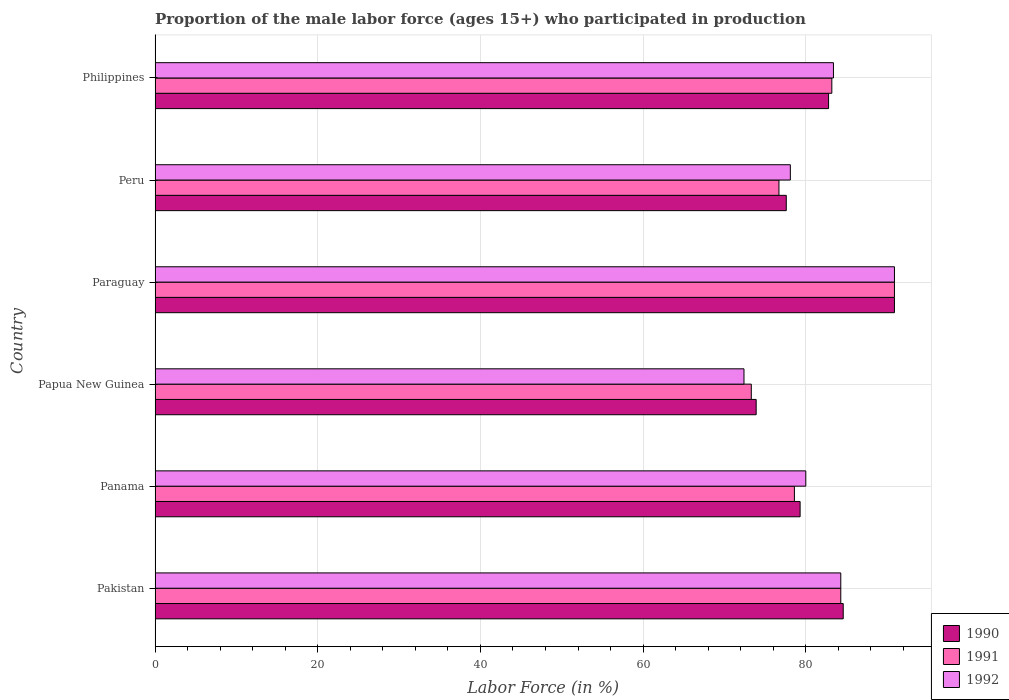How many groups of bars are there?
Offer a very short reply. 6. Are the number of bars per tick equal to the number of legend labels?
Your response must be concise. Yes. Are the number of bars on each tick of the Y-axis equal?
Ensure brevity in your answer.  Yes. What is the label of the 2nd group of bars from the top?
Give a very brief answer. Peru. What is the proportion of the male labor force who participated in production in 1991 in Papua New Guinea?
Ensure brevity in your answer.  73.3. Across all countries, what is the maximum proportion of the male labor force who participated in production in 1990?
Provide a short and direct response. 90.9. Across all countries, what is the minimum proportion of the male labor force who participated in production in 1991?
Provide a short and direct response. 73.3. In which country was the proportion of the male labor force who participated in production in 1991 maximum?
Your answer should be very brief. Paraguay. In which country was the proportion of the male labor force who participated in production in 1991 minimum?
Your answer should be very brief. Papua New Guinea. What is the total proportion of the male labor force who participated in production in 1991 in the graph?
Provide a short and direct response. 487. What is the difference between the proportion of the male labor force who participated in production in 1992 in Pakistan and that in Paraguay?
Your answer should be compact. -6.6. What is the difference between the proportion of the male labor force who participated in production in 1990 in Peru and the proportion of the male labor force who participated in production in 1992 in Pakistan?
Your answer should be very brief. -6.7. What is the average proportion of the male labor force who participated in production in 1991 per country?
Offer a very short reply. 81.17. In how many countries, is the proportion of the male labor force who participated in production in 1992 greater than 80 %?
Offer a very short reply. 3. What is the ratio of the proportion of the male labor force who participated in production in 1991 in Panama to that in Paraguay?
Provide a short and direct response. 0.86. Is the difference between the proportion of the male labor force who participated in production in 1991 in Papua New Guinea and Peru greater than the difference between the proportion of the male labor force who participated in production in 1990 in Papua New Guinea and Peru?
Offer a terse response. Yes. What is the difference between the highest and the second highest proportion of the male labor force who participated in production in 1992?
Your answer should be very brief. 6.6. What is the difference between the highest and the lowest proportion of the male labor force who participated in production in 1992?
Offer a very short reply. 18.5. In how many countries, is the proportion of the male labor force who participated in production in 1990 greater than the average proportion of the male labor force who participated in production in 1990 taken over all countries?
Your response must be concise. 3. Is the sum of the proportion of the male labor force who participated in production in 1991 in Panama and Peru greater than the maximum proportion of the male labor force who participated in production in 1990 across all countries?
Make the answer very short. Yes. What does the 1st bar from the top in Peru represents?
Your response must be concise. 1992. How many bars are there?
Give a very brief answer. 18. What is the difference between two consecutive major ticks on the X-axis?
Provide a short and direct response. 20. Does the graph contain any zero values?
Your answer should be very brief. No. How many legend labels are there?
Your response must be concise. 3. How are the legend labels stacked?
Your response must be concise. Vertical. What is the title of the graph?
Give a very brief answer. Proportion of the male labor force (ages 15+) who participated in production. Does "1984" appear as one of the legend labels in the graph?
Your answer should be compact. No. What is the label or title of the Y-axis?
Offer a terse response. Country. What is the Labor Force (in %) of 1990 in Pakistan?
Provide a short and direct response. 84.6. What is the Labor Force (in %) of 1991 in Pakistan?
Your answer should be compact. 84.3. What is the Labor Force (in %) in 1992 in Pakistan?
Give a very brief answer. 84.3. What is the Labor Force (in %) in 1990 in Panama?
Provide a short and direct response. 79.3. What is the Labor Force (in %) in 1991 in Panama?
Make the answer very short. 78.6. What is the Labor Force (in %) of 1990 in Papua New Guinea?
Your response must be concise. 73.9. What is the Labor Force (in %) in 1991 in Papua New Guinea?
Provide a succinct answer. 73.3. What is the Labor Force (in %) in 1992 in Papua New Guinea?
Provide a short and direct response. 72.4. What is the Labor Force (in %) of 1990 in Paraguay?
Keep it short and to the point. 90.9. What is the Labor Force (in %) in 1991 in Paraguay?
Make the answer very short. 90.9. What is the Labor Force (in %) of 1992 in Paraguay?
Ensure brevity in your answer.  90.9. What is the Labor Force (in %) in 1990 in Peru?
Your response must be concise. 77.6. What is the Labor Force (in %) in 1991 in Peru?
Your response must be concise. 76.7. What is the Labor Force (in %) in 1992 in Peru?
Give a very brief answer. 78.1. What is the Labor Force (in %) of 1990 in Philippines?
Provide a short and direct response. 82.8. What is the Labor Force (in %) of 1991 in Philippines?
Make the answer very short. 83.2. What is the Labor Force (in %) in 1992 in Philippines?
Provide a succinct answer. 83.4. Across all countries, what is the maximum Labor Force (in %) in 1990?
Provide a short and direct response. 90.9. Across all countries, what is the maximum Labor Force (in %) of 1991?
Provide a short and direct response. 90.9. Across all countries, what is the maximum Labor Force (in %) of 1992?
Your answer should be compact. 90.9. Across all countries, what is the minimum Labor Force (in %) of 1990?
Ensure brevity in your answer.  73.9. Across all countries, what is the minimum Labor Force (in %) of 1991?
Offer a terse response. 73.3. Across all countries, what is the minimum Labor Force (in %) in 1992?
Give a very brief answer. 72.4. What is the total Labor Force (in %) of 1990 in the graph?
Provide a short and direct response. 489.1. What is the total Labor Force (in %) of 1991 in the graph?
Ensure brevity in your answer.  487. What is the total Labor Force (in %) in 1992 in the graph?
Make the answer very short. 489.1. What is the difference between the Labor Force (in %) in 1991 in Pakistan and that in Panama?
Your response must be concise. 5.7. What is the difference between the Labor Force (in %) of 1992 in Pakistan and that in Panama?
Provide a succinct answer. 4.3. What is the difference between the Labor Force (in %) of 1990 in Pakistan and that in Paraguay?
Your answer should be compact. -6.3. What is the difference between the Labor Force (in %) in 1991 in Pakistan and that in Paraguay?
Give a very brief answer. -6.6. What is the difference between the Labor Force (in %) in 1990 in Pakistan and that in Peru?
Provide a succinct answer. 7. What is the difference between the Labor Force (in %) of 1992 in Pakistan and that in Philippines?
Provide a short and direct response. 0.9. What is the difference between the Labor Force (in %) of 1990 in Panama and that in Papua New Guinea?
Offer a terse response. 5.4. What is the difference between the Labor Force (in %) in 1991 in Panama and that in Paraguay?
Give a very brief answer. -12.3. What is the difference between the Labor Force (in %) in 1992 in Panama and that in Paraguay?
Provide a succinct answer. -10.9. What is the difference between the Labor Force (in %) in 1990 in Panama and that in Peru?
Provide a short and direct response. 1.7. What is the difference between the Labor Force (in %) of 1991 in Panama and that in Peru?
Provide a succinct answer. 1.9. What is the difference between the Labor Force (in %) of 1992 in Panama and that in Peru?
Provide a succinct answer. 1.9. What is the difference between the Labor Force (in %) in 1991 in Panama and that in Philippines?
Your answer should be compact. -4.6. What is the difference between the Labor Force (in %) of 1991 in Papua New Guinea and that in Paraguay?
Provide a succinct answer. -17.6. What is the difference between the Labor Force (in %) in 1992 in Papua New Guinea and that in Paraguay?
Ensure brevity in your answer.  -18.5. What is the difference between the Labor Force (in %) of 1990 in Papua New Guinea and that in Peru?
Make the answer very short. -3.7. What is the difference between the Labor Force (in %) of 1992 in Papua New Guinea and that in Peru?
Provide a succinct answer. -5.7. What is the difference between the Labor Force (in %) of 1990 in Papua New Guinea and that in Philippines?
Make the answer very short. -8.9. What is the difference between the Labor Force (in %) of 1991 in Paraguay and that in Peru?
Give a very brief answer. 14.2. What is the difference between the Labor Force (in %) of 1990 in Peru and that in Philippines?
Keep it short and to the point. -5.2. What is the difference between the Labor Force (in %) of 1991 in Peru and that in Philippines?
Ensure brevity in your answer.  -6.5. What is the difference between the Labor Force (in %) in 1991 in Pakistan and the Labor Force (in %) in 1992 in Panama?
Provide a succinct answer. 4.3. What is the difference between the Labor Force (in %) of 1990 in Pakistan and the Labor Force (in %) of 1992 in Papua New Guinea?
Offer a very short reply. 12.2. What is the difference between the Labor Force (in %) in 1991 in Pakistan and the Labor Force (in %) in 1992 in Papua New Guinea?
Ensure brevity in your answer.  11.9. What is the difference between the Labor Force (in %) of 1990 in Pakistan and the Labor Force (in %) of 1991 in Paraguay?
Provide a short and direct response. -6.3. What is the difference between the Labor Force (in %) of 1990 in Pakistan and the Labor Force (in %) of 1992 in Paraguay?
Offer a terse response. -6.3. What is the difference between the Labor Force (in %) in 1990 in Pakistan and the Labor Force (in %) in 1991 in Philippines?
Offer a terse response. 1.4. What is the difference between the Labor Force (in %) in 1990 in Pakistan and the Labor Force (in %) in 1992 in Philippines?
Your answer should be compact. 1.2. What is the difference between the Labor Force (in %) in 1991 in Pakistan and the Labor Force (in %) in 1992 in Philippines?
Your response must be concise. 0.9. What is the difference between the Labor Force (in %) in 1990 in Panama and the Labor Force (in %) in 1991 in Papua New Guinea?
Offer a very short reply. 6. What is the difference between the Labor Force (in %) of 1990 in Panama and the Labor Force (in %) of 1991 in Paraguay?
Keep it short and to the point. -11.6. What is the difference between the Labor Force (in %) of 1990 in Panama and the Labor Force (in %) of 1992 in Paraguay?
Make the answer very short. -11.6. What is the difference between the Labor Force (in %) of 1991 in Panama and the Labor Force (in %) of 1992 in Paraguay?
Keep it short and to the point. -12.3. What is the difference between the Labor Force (in %) in 1991 in Panama and the Labor Force (in %) in 1992 in Philippines?
Make the answer very short. -4.8. What is the difference between the Labor Force (in %) in 1991 in Papua New Guinea and the Labor Force (in %) in 1992 in Paraguay?
Provide a short and direct response. -17.6. What is the difference between the Labor Force (in %) in 1990 in Papua New Guinea and the Labor Force (in %) in 1991 in Peru?
Offer a terse response. -2.8. What is the difference between the Labor Force (in %) of 1990 in Papua New Guinea and the Labor Force (in %) of 1991 in Philippines?
Your answer should be very brief. -9.3. What is the difference between the Labor Force (in %) in 1990 in Papua New Guinea and the Labor Force (in %) in 1992 in Philippines?
Your answer should be very brief. -9.5. What is the difference between the Labor Force (in %) of 1990 in Paraguay and the Labor Force (in %) of 1991 in Peru?
Your answer should be very brief. 14.2. What is the difference between the Labor Force (in %) of 1991 in Paraguay and the Labor Force (in %) of 1992 in Philippines?
Offer a very short reply. 7.5. What is the difference between the Labor Force (in %) in 1990 in Peru and the Labor Force (in %) in 1991 in Philippines?
Your response must be concise. -5.6. What is the difference between the Labor Force (in %) in 1990 in Peru and the Labor Force (in %) in 1992 in Philippines?
Offer a very short reply. -5.8. What is the difference between the Labor Force (in %) of 1991 in Peru and the Labor Force (in %) of 1992 in Philippines?
Offer a very short reply. -6.7. What is the average Labor Force (in %) in 1990 per country?
Make the answer very short. 81.52. What is the average Labor Force (in %) in 1991 per country?
Keep it short and to the point. 81.17. What is the average Labor Force (in %) of 1992 per country?
Offer a terse response. 81.52. What is the difference between the Labor Force (in %) in 1990 and Labor Force (in %) in 1991 in Pakistan?
Make the answer very short. 0.3. What is the difference between the Labor Force (in %) in 1991 and Labor Force (in %) in 1992 in Panama?
Provide a succinct answer. -1.4. What is the difference between the Labor Force (in %) of 1990 and Labor Force (in %) of 1992 in Papua New Guinea?
Provide a short and direct response. 1.5. What is the difference between the Labor Force (in %) of 1990 and Labor Force (in %) of 1991 in Paraguay?
Give a very brief answer. 0. What is the difference between the Labor Force (in %) of 1991 and Labor Force (in %) of 1992 in Paraguay?
Your response must be concise. 0. What is the difference between the Labor Force (in %) of 1990 and Labor Force (in %) of 1992 in Peru?
Give a very brief answer. -0.5. What is the difference between the Labor Force (in %) in 1990 and Labor Force (in %) in 1991 in Philippines?
Offer a very short reply. -0.4. What is the difference between the Labor Force (in %) of 1991 and Labor Force (in %) of 1992 in Philippines?
Provide a short and direct response. -0.2. What is the ratio of the Labor Force (in %) in 1990 in Pakistan to that in Panama?
Your answer should be compact. 1.07. What is the ratio of the Labor Force (in %) of 1991 in Pakistan to that in Panama?
Make the answer very short. 1.07. What is the ratio of the Labor Force (in %) in 1992 in Pakistan to that in Panama?
Ensure brevity in your answer.  1.05. What is the ratio of the Labor Force (in %) in 1990 in Pakistan to that in Papua New Guinea?
Give a very brief answer. 1.14. What is the ratio of the Labor Force (in %) of 1991 in Pakistan to that in Papua New Guinea?
Your answer should be compact. 1.15. What is the ratio of the Labor Force (in %) in 1992 in Pakistan to that in Papua New Guinea?
Ensure brevity in your answer.  1.16. What is the ratio of the Labor Force (in %) of 1990 in Pakistan to that in Paraguay?
Offer a terse response. 0.93. What is the ratio of the Labor Force (in %) of 1991 in Pakistan to that in Paraguay?
Your response must be concise. 0.93. What is the ratio of the Labor Force (in %) in 1992 in Pakistan to that in Paraguay?
Provide a short and direct response. 0.93. What is the ratio of the Labor Force (in %) of 1990 in Pakistan to that in Peru?
Your answer should be very brief. 1.09. What is the ratio of the Labor Force (in %) in 1991 in Pakistan to that in Peru?
Keep it short and to the point. 1.1. What is the ratio of the Labor Force (in %) of 1992 in Pakistan to that in Peru?
Make the answer very short. 1.08. What is the ratio of the Labor Force (in %) in 1990 in Pakistan to that in Philippines?
Ensure brevity in your answer.  1.02. What is the ratio of the Labor Force (in %) of 1991 in Pakistan to that in Philippines?
Offer a very short reply. 1.01. What is the ratio of the Labor Force (in %) in 1992 in Pakistan to that in Philippines?
Offer a terse response. 1.01. What is the ratio of the Labor Force (in %) in 1990 in Panama to that in Papua New Guinea?
Ensure brevity in your answer.  1.07. What is the ratio of the Labor Force (in %) in 1991 in Panama to that in Papua New Guinea?
Offer a very short reply. 1.07. What is the ratio of the Labor Force (in %) of 1992 in Panama to that in Papua New Guinea?
Your answer should be very brief. 1.1. What is the ratio of the Labor Force (in %) of 1990 in Panama to that in Paraguay?
Ensure brevity in your answer.  0.87. What is the ratio of the Labor Force (in %) in 1991 in Panama to that in Paraguay?
Give a very brief answer. 0.86. What is the ratio of the Labor Force (in %) in 1992 in Panama to that in Paraguay?
Ensure brevity in your answer.  0.88. What is the ratio of the Labor Force (in %) of 1990 in Panama to that in Peru?
Ensure brevity in your answer.  1.02. What is the ratio of the Labor Force (in %) in 1991 in Panama to that in Peru?
Make the answer very short. 1.02. What is the ratio of the Labor Force (in %) of 1992 in Panama to that in Peru?
Provide a succinct answer. 1.02. What is the ratio of the Labor Force (in %) of 1990 in Panama to that in Philippines?
Your answer should be very brief. 0.96. What is the ratio of the Labor Force (in %) of 1991 in Panama to that in Philippines?
Offer a terse response. 0.94. What is the ratio of the Labor Force (in %) of 1992 in Panama to that in Philippines?
Ensure brevity in your answer.  0.96. What is the ratio of the Labor Force (in %) of 1990 in Papua New Guinea to that in Paraguay?
Your response must be concise. 0.81. What is the ratio of the Labor Force (in %) of 1991 in Papua New Guinea to that in Paraguay?
Make the answer very short. 0.81. What is the ratio of the Labor Force (in %) in 1992 in Papua New Guinea to that in Paraguay?
Your answer should be compact. 0.8. What is the ratio of the Labor Force (in %) in 1990 in Papua New Guinea to that in Peru?
Your response must be concise. 0.95. What is the ratio of the Labor Force (in %) in 1991 in Papua New Guinea to that in Peru?
Make the answer very short. 0.96. What is the ratio of the Labor Force (in %) of 1992 in Papua New Guinea to that in Peru?
Your answer should be compact. 0.93. What is the ratio of the Labor Force (in %) in 1990 in Papua New Guinea to that in Philippines?
Your answer should be compact. 0.89. What is the ratio of the Labor Force (in %) in 1991 in Papua New Guinea to that in Philippines?
Your answer should be very brief. 0.88. What is the ratio of the Labor Force (in %) of 1992 in Papua New Guinea to that in Philippines?
Provide a short and direct response. 0.87. What is the ratio of the Labor Force (in %) in 1990 in Paraguay to that in Peru?
Your answer should be very brief. 1.17. What is the ratio of the Labor Force (in %) in 1991 in Paraguay to that in Peru?
Your answer should be very brief. 1.19. What is the ratio of the Labor Force (in %) in 1992 in Paraguay to that in Peru?
Provide a succinct answer. 1.16. What is the ratio of the Labor Force (in %) in 1990 in Paraguay to that in Philippines?
Provide a short and direct response. 1.1. What is the ratio of the Labor Force (in %) of 1991 in Paraguay to that in Philippines?
Ensure brevity in your answer.  1.09. What is the ratio of the Labor Force (in %) of 1992 in Paraguay to that in Philippines?
Ensure brevity in your answer.  1.09. What is the ratio of the Labor Force (in %) in 1990 in Peru to that in Philippines?
Provide a short and direct response. 0.94. What is the ratio of the Labor Force (in %) in 1991 in Peru to that in Philippines?
Keep it short and to the point. 0.92. What is the ratio of the Labor Force (in %) of 1992 in Peru to that in Philippines?
Give a very brief answer. 0.94. What is the difference between the highest and the second highest Labor Force (in %) in 1990?
Your answer should be compact. 6.3. What is the difference between the highest and the second highest Labor Force (in %) in 1991?
Provide a short and direct response. 6.6. What is the difference between the highest and the lowest Labor Force (in %) of 1990?
Make the answer very short. 17. What is the difference between the highest and the lowest Labor Force (in %) in 1991?
Ensure brevity in your answer.  17.6. 